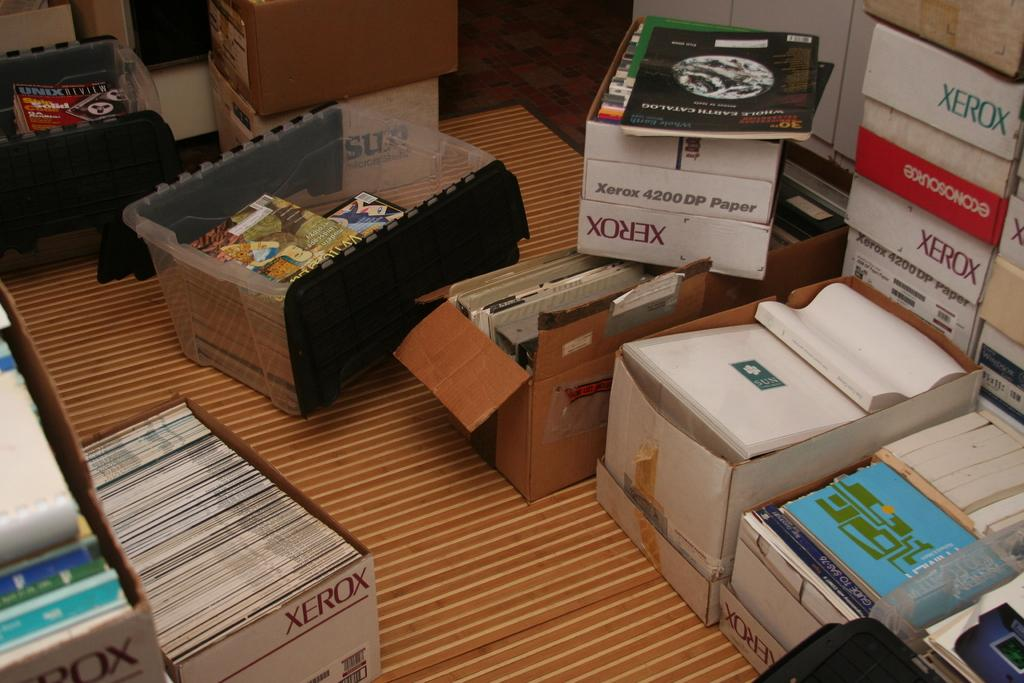Provide a one-sentence caption for the provided image. several Xerox boxes are piled around on the floor. 